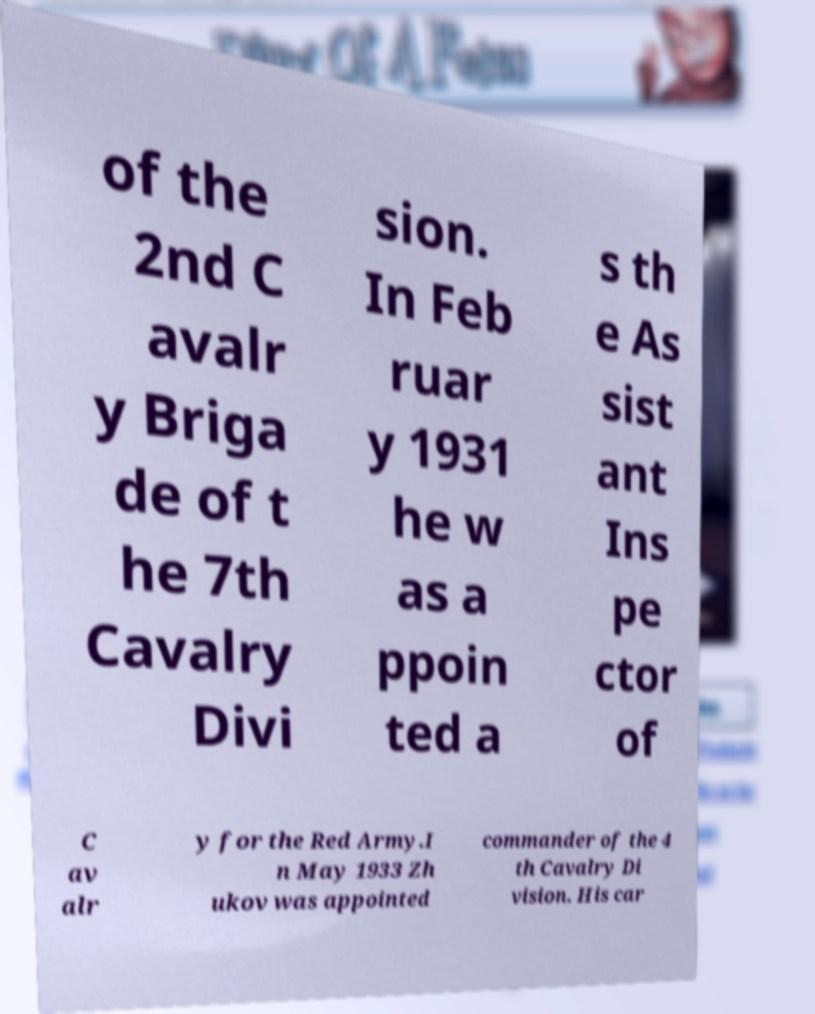Please read and relay the text visible in this image. What does it say? of the 2nd C avalr y Briga de of t he 7th Cavalry Divi sion. In Feb ruar y 1931 he w as a ppoin ted a s th e As sist ant Ins pe ctor of C av alr y for the Red Army.I n May 1933 Zh ukov was appointed commander of the 4 th Cavalry Di vision. His car 